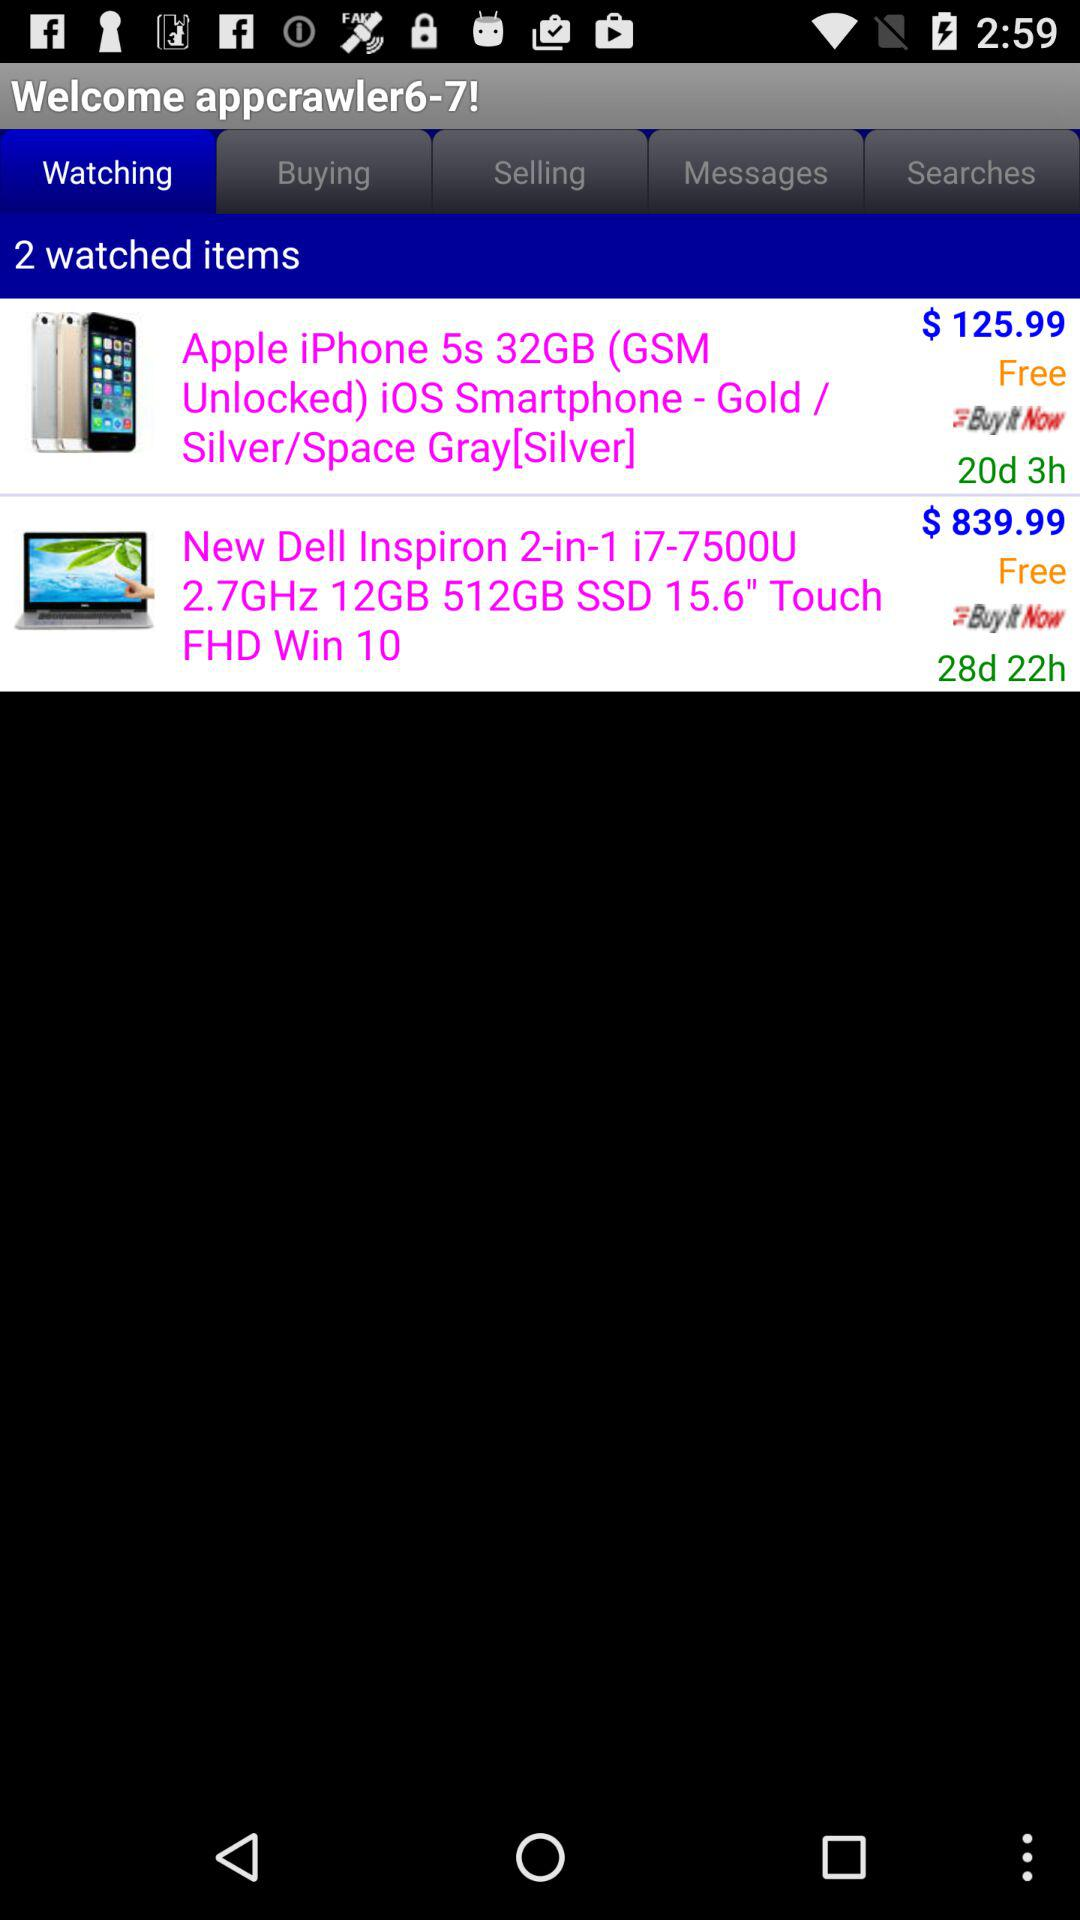What is the application name?
When the provided information is insufficient, respond with <no answer>. <no answer> 